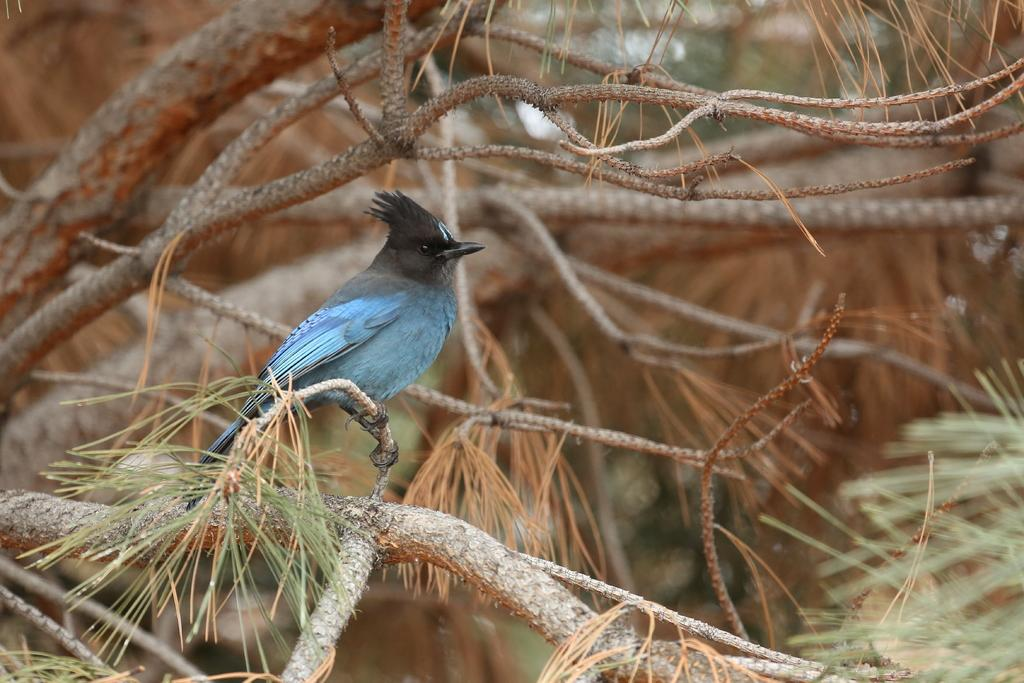What type of animal is in the image? There is a bird in the image. Where is the bird located? The bird is on a tree. How many zebras can be seen grazing on the ground in the image? There are no zebras present in the image. Are there any chairs visible in the image? There is no mention of chairs in the provided facts, and therefore we cannot determine if any are present in the image. 